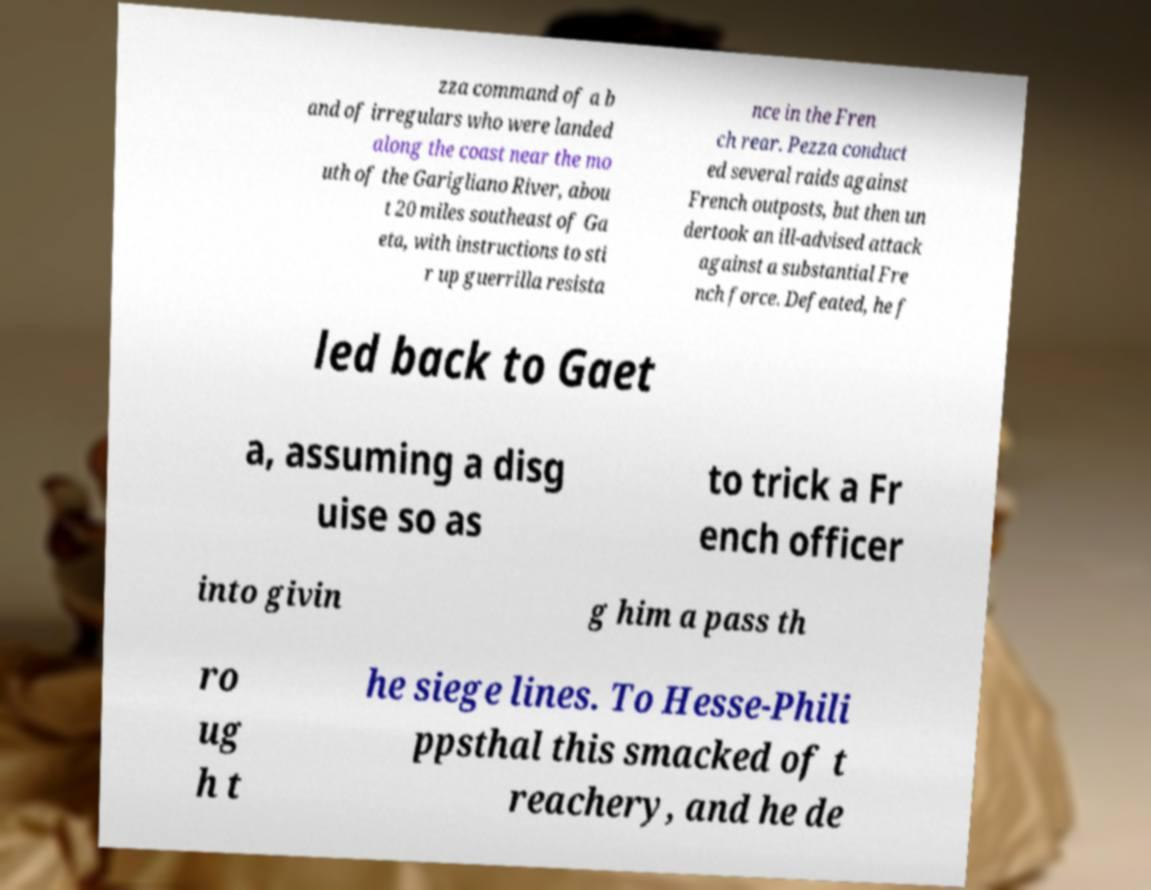Please read and relay the text visible in this image. What does it say? zza command of a b and of irregulars who were landed along the coast near the mo uth of the Garigliano River, abou t 20 miles southeast of Ga eta, with instructions to sti r up guerrilla resista nce in the Fren ch rear. Pezza conduct ed several raids against French outposts, but then un dertook an ill-advised attack against a substantial Fre nch force. Defeated, he f led back to Gaet a, assuming a disg uise so as to trick a Fr ench officer into givin g him a pass th ro ug h t he siege lines. To Hesse-Phili ppsthal this smacked of t reachery, and he de 